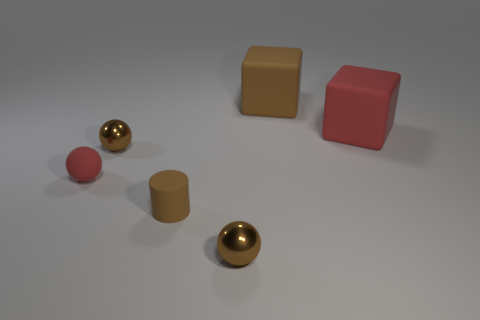The tiny brown ball behind the small brown sphere in front of the tiny red rubber thing is made of what material?
Provide a short and direct response. Metal. Are there fewer blocks that are to the right of the small red rubber object than red spheres that are behind the brown cube?
Offer a very short reply. No. What material is the block that is the same color as the tiny matte cylinder?
Offer a terse response. Rubber. Is there any other thing that is the same shape as the tiny brown rubber object?
Provide a succinct answer. No. There is a tiny brown sphere behind the small red rubber thing; what is its material?
Ensure brevity in your answer.  Metal. Is there anything else that has the same size as the red block?
Your answer should be compact. Yes. There is a big brown rubber object; are there any small brown rubber things behind it?
Your answer should be very brief. No. What is the shape of the small brown rubber object?
Your answer should be very brief. Cylinder. What number of objects are big objects in front of the big brown cube or red spheres?
Make the answer very short. 2. What number of other objects are the same color as the cylinder?
Provide a succinct answer. 3. 